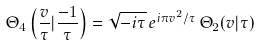<formula> <loc_0><loc_0><loc_500><loc_500>\Theta _ { 4 } \left ( \frac { v } { \tau } | \frac { - 1 } { \tau } \right ) = \sqrt { - i \tau } \, e ^ { i \pi v ^ { 2 } / \tau } \, \Theta _ { 2 } ( v | \tau )</formula> 